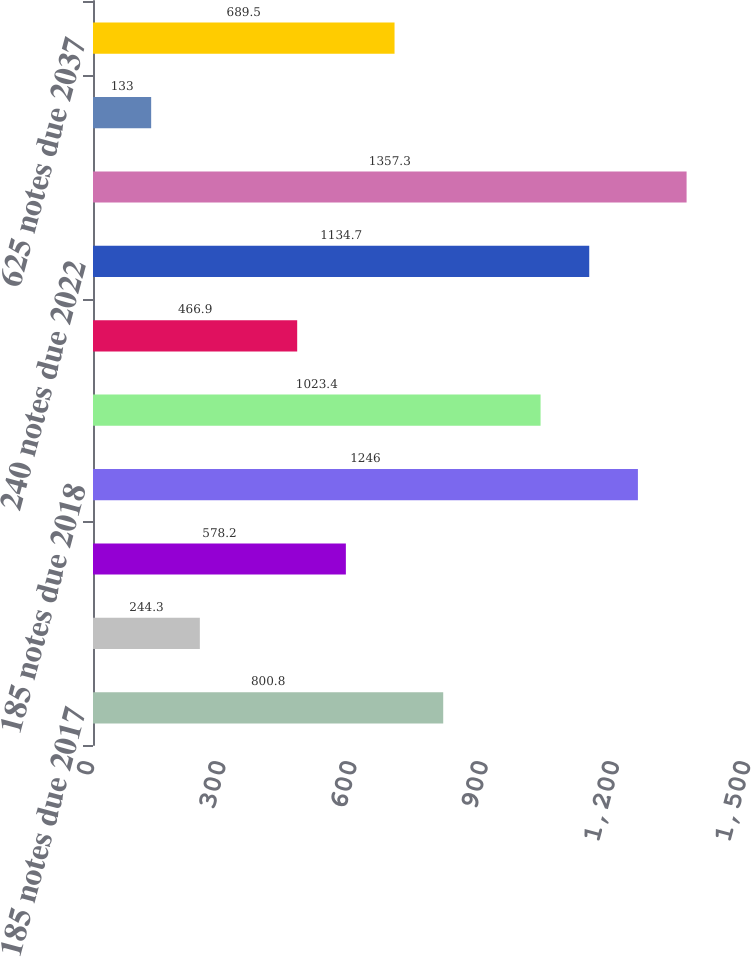Convert chart. <chart><loc_0><loc_0><loc_500><loc_500><bar_chart><fcel>185 notes due 2017<fcel>Variable-rate loan due 2017<fcel>5375 notes due 2018<fcel>185 notes due 2018<fcel>45 notes due 2019<fcel>425 notes due 2020<fcel>240 notes due 2022<fcel>32 notes due 2023<fcel>6625 debentures due 2028<fcel>625 notes due 2037<nl><fcel>800.8<fcel>244.3<fcel>578.2<fcel>1246<fcel>1023.4<fcel>466.9<fcel>1134.7<fcel>1357.3<fcel>133<fcel>689.5<nl></chart> 